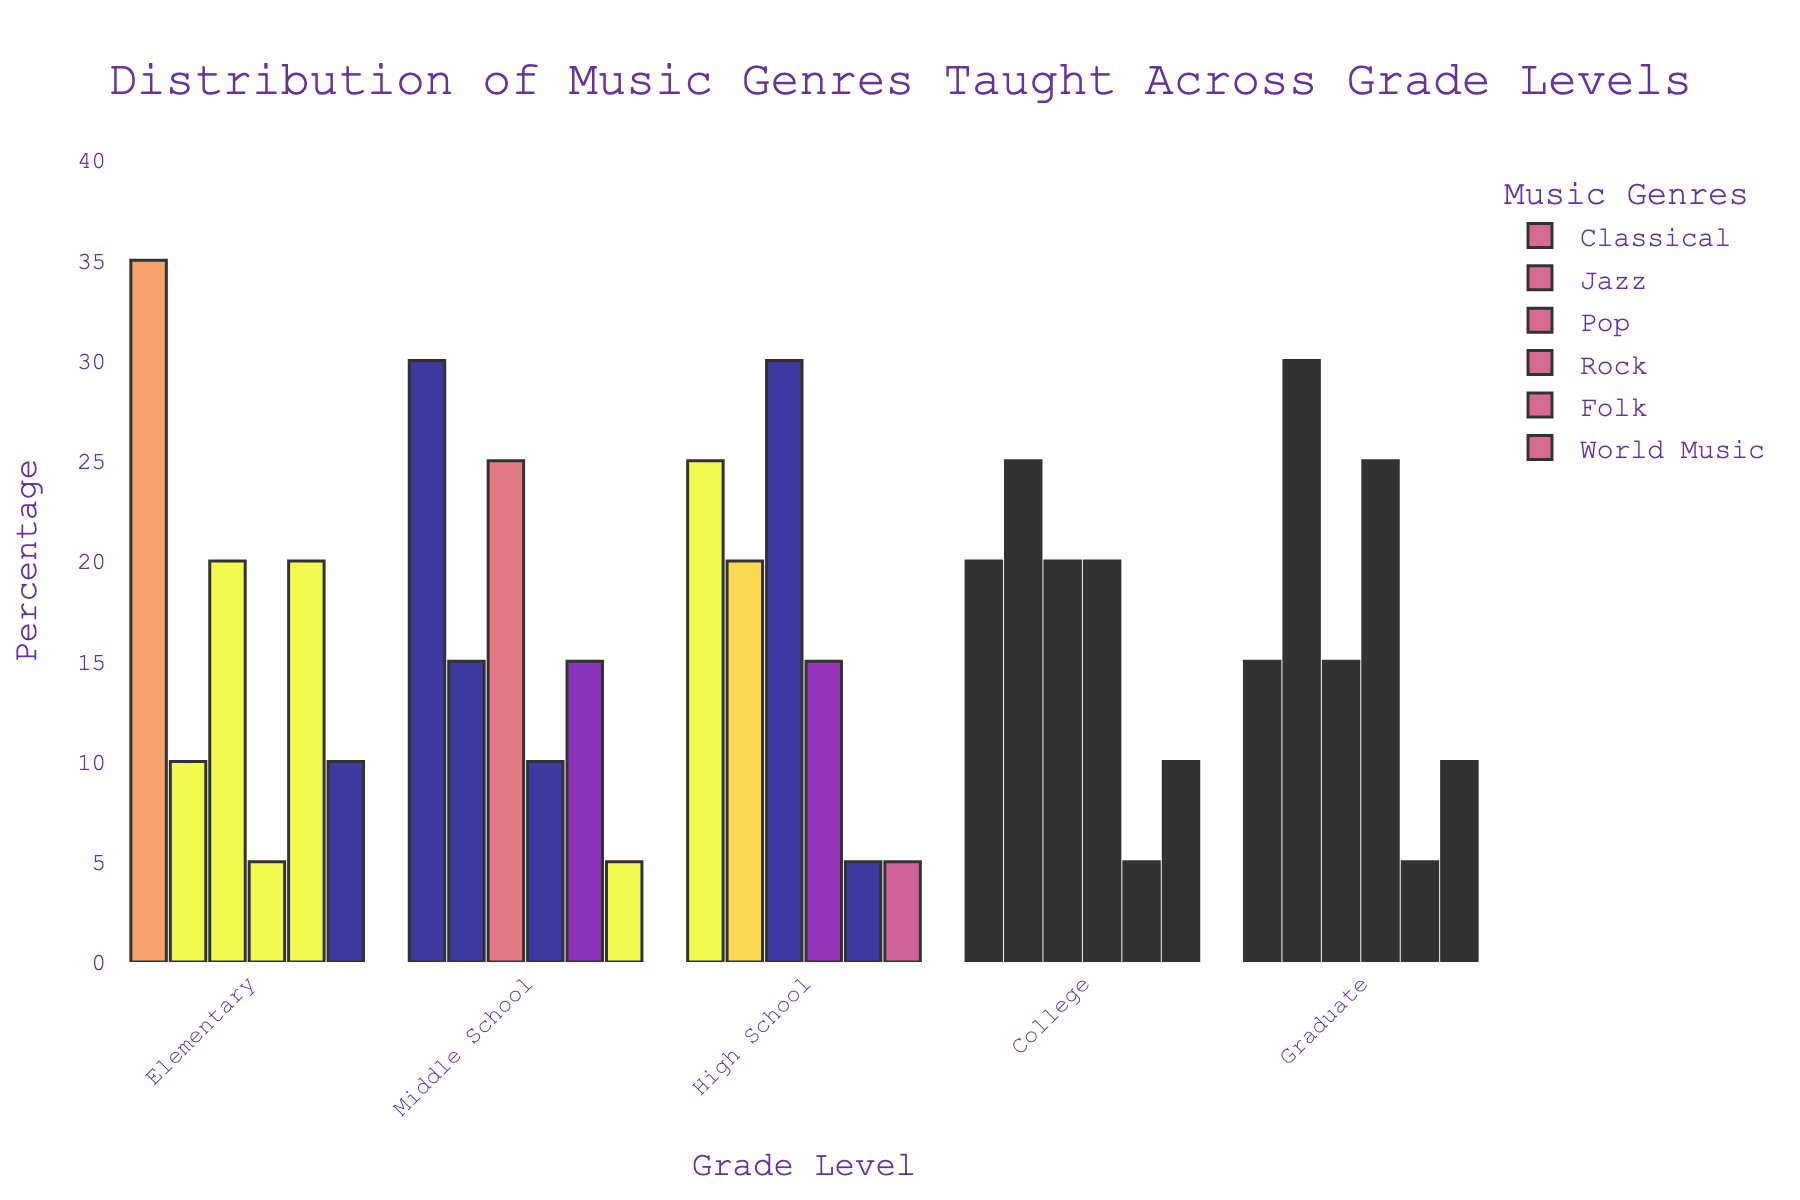Which grade level has the highest percentage of Jazz taught? By looking at the heights of the bars representing Jazz, the Graduate level has the highest bar.
Answer: Graduate Which music genre is least taught in Elementary grade level? By comparing the heights of the bars for each genre in the Elementary grade level, Rock has the smallest bar.
Answer: Rock How many more percentage points is Pop taught in High School compared to Middle School? The height of the Pop bar for High School is 30 and for Middle School is 25. The difference is 30 - 25.
Answer: 5 Which music genres are taught equally in Middle School? By comparing the heights of bars for genres in Middle School, World Music and Graduate are both at 5.
Answer: World Music, Graduate Is there any grade level where Folk music is taught more than Pop music? By comparing the bars for Folk and Pop across all grade levels, there is no grade level where the height of the Folk bar is greater than the Pop bar.
Answer: No What percentage of Classical music is taught in College? By inspecting the height of the Classical bar for College, it is 20.
Answer: 20 What is the total percentage of Rock music taught across all grade levels? Summing the heights of the Rock bars across all grade levels, 5 + 10 + 15 + 20 + 25 = 75.
Answer: 75 How does the distribution of music genres in Graduate compare to Elementary? The Graduate level has 15 in Classical, 30 in Jazz, 15 in Pop, 25 in Rock, 5 in Folk, and 10 in World Music, whereas Elementary has 35 in Classical, 10 in Jazz, 20 in Pop, 5 in Rock, 20 in Folk, and 10 in World Music. Graduate has higher Jazz and Rock, lower Classical, Pop, and Folk, and the same World Music.
Answer: Higher Jazz and Rock, lower Classical, Pop, and Folk, same World Music 